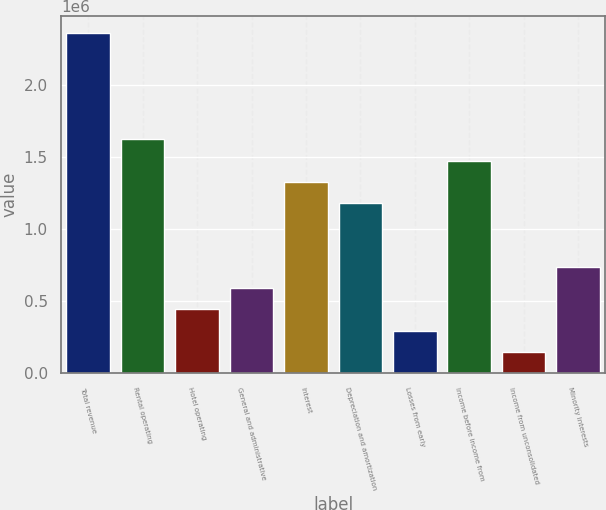Convert chart to OTSL. <chart><loc_0><loc_0><loc_500><loc_500><bar_chart><fcel>Total revenue<fcel>Rental operating<fcel>Hotel operating<fcel>General and administrative<fcel>Interest<fcel>Depreciation and amortization<fcel>Losses from early<fcel>Income before income from<fcel>Income from unconsolidated<fcel>Minority interests<nl><fcel>2.36413e+06<fcel>1.62534e+06<fcel>443281<fcel>591039<fcel>1.32983e+06<fcel>1.18207e+06<fcel>295523<fcel>1.47759e+06<fcel>147765<fcel>738797<nl></chart> 